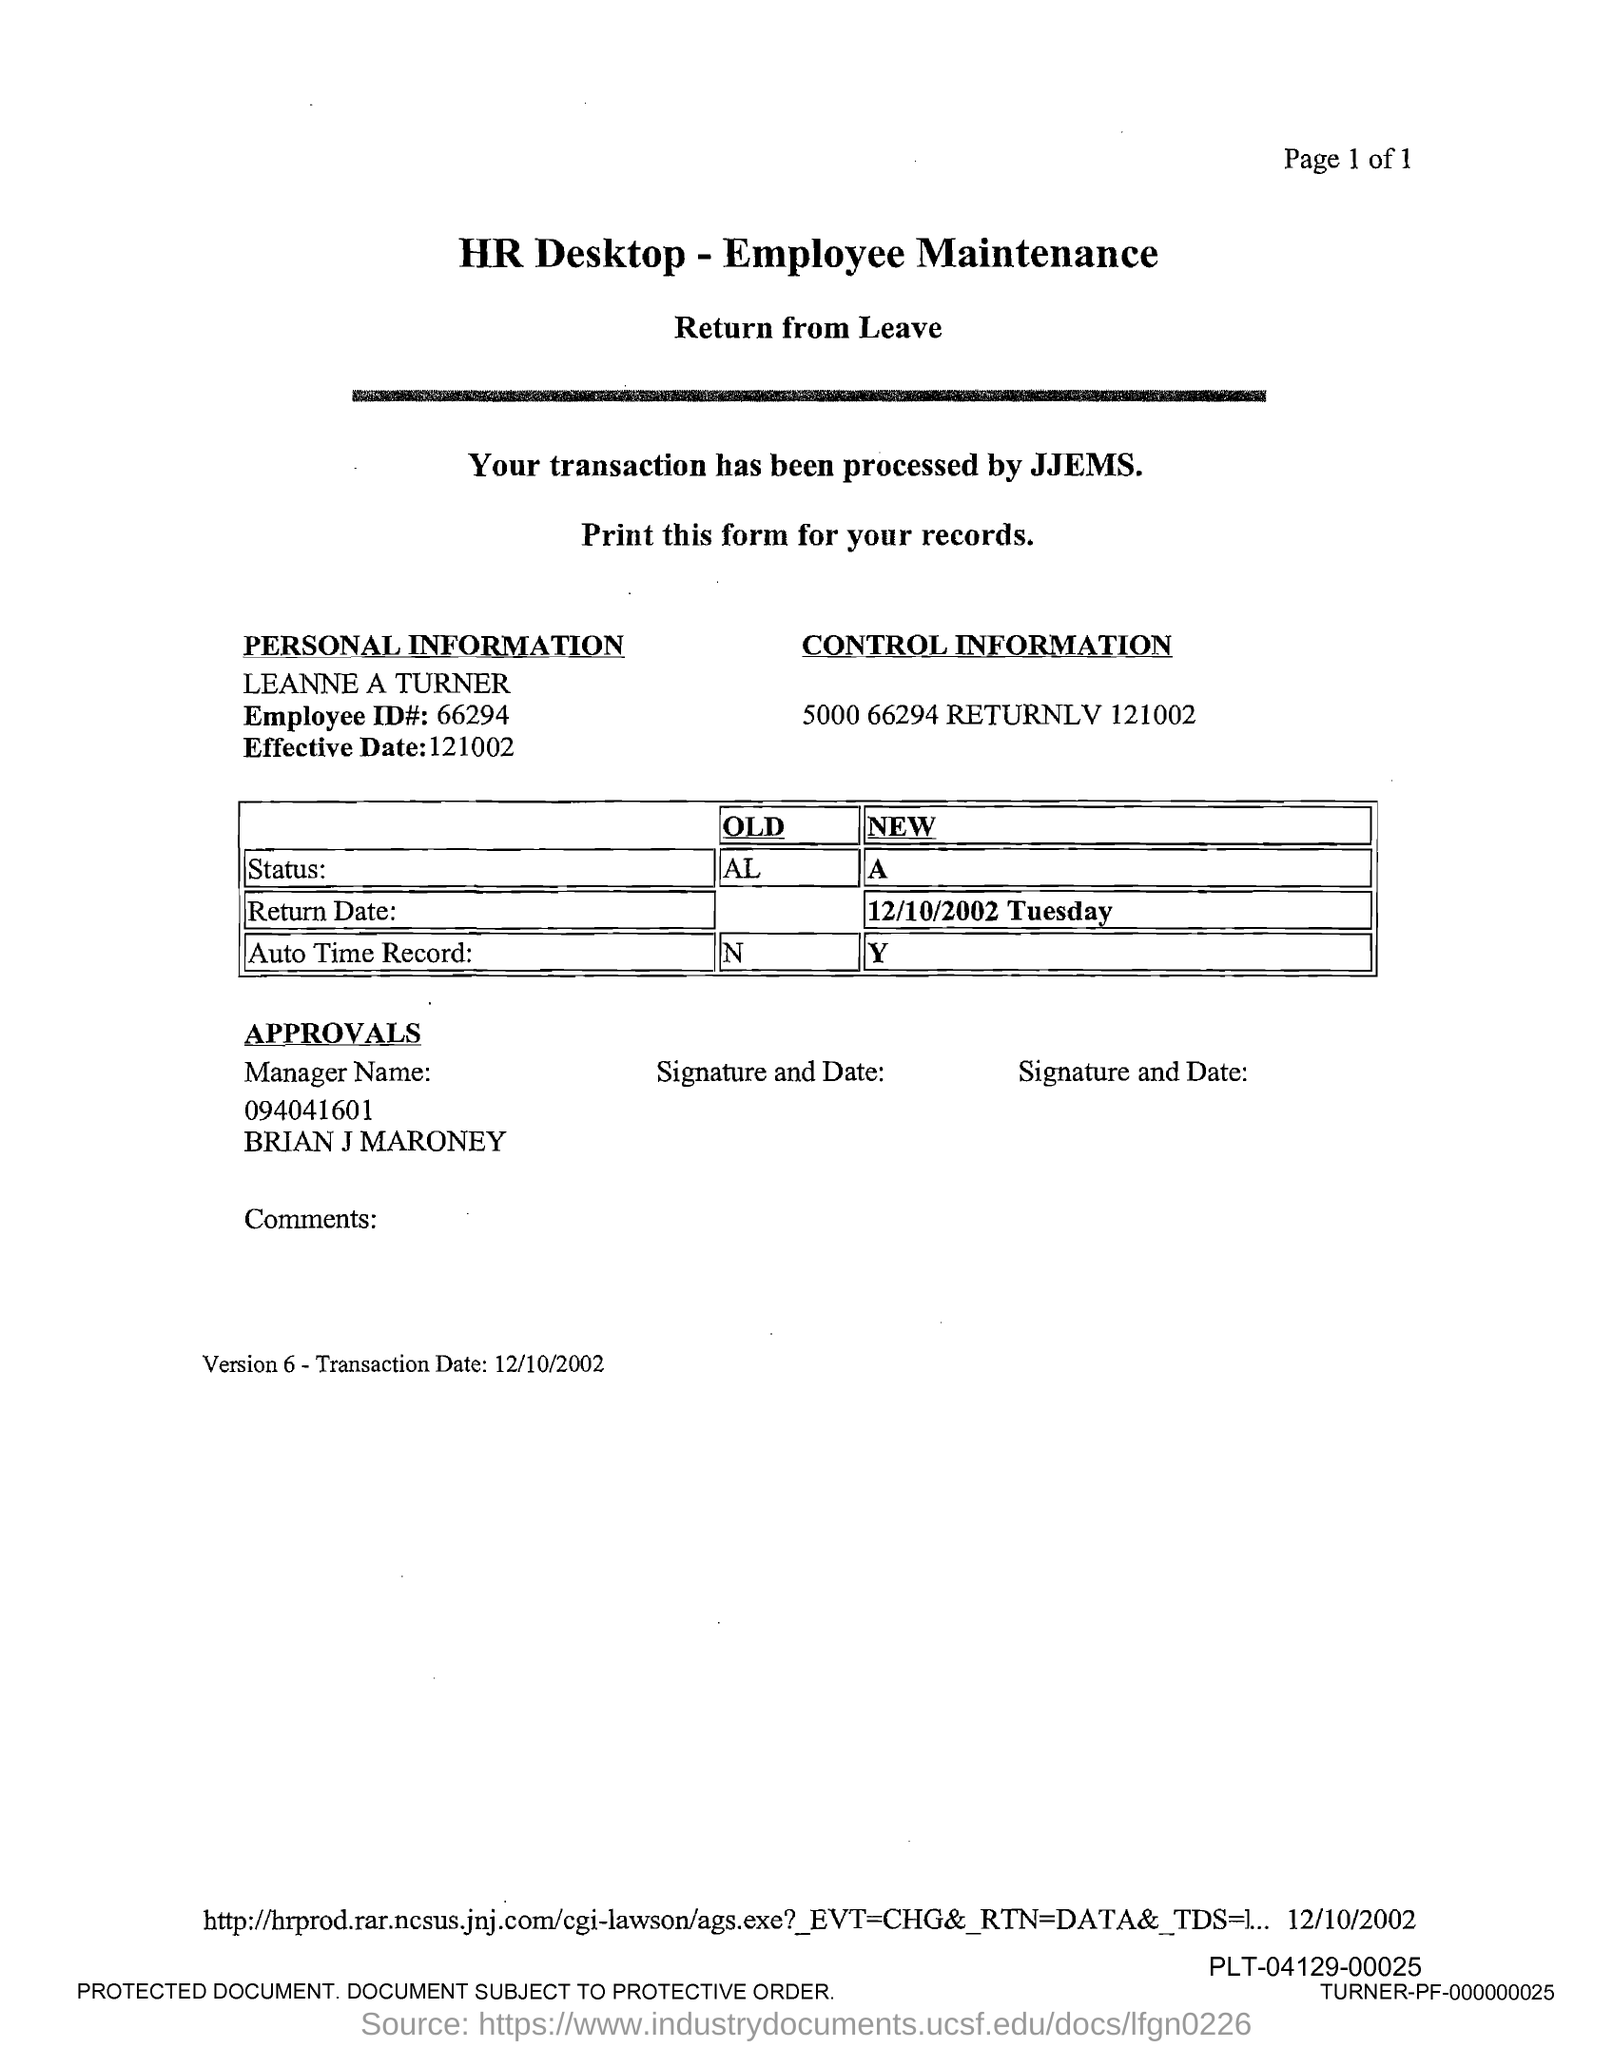Outline some significant characteristics in this image. The text "what is the employee id# ? 66294.." is a question asking for information about an employee's identification number. What is the effective date? Please provide the date in the format of 121002... 